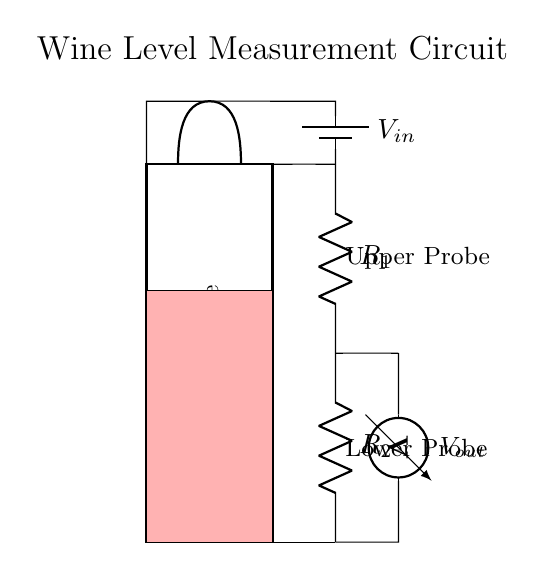What component is used to sense the voltage in this circuit? The component used to sense the voltage is a voltmeter, which is designed to measure the potential difference across a component.
Answer: voltmeter What are the two resistors labeled in this circuit? The two resistors in the circuit are labeled R1 and R2, which are part of the voltage divider setup to create the output voltage.
Answer: R1 and R2 What does the red area in the circuit diagram represent? The red area in the circuit diagram represents the current liquid level inside the wine bottle, indicating how much wine is present.
Answer: liquid level How is the voltage output measured in this circuit? The voltage output is measured by connecting the voltmeter between the upper and lower probes, which indicate where the measurement occurs in relation to the resistors.
Answer: between the upper and lower probes What is the purpose of the voltage divider in this circuit? The purpose of the voltage divider is to reduce the input voltage to a lower level that can be measured precisely, allowing for accurate determination of the wine bottle level.
Answer: to reduce the input voltage What would happen to the output voltage if R1 is increased? If R1 is increased while R2 stays the same, the output voltage will increase because the ratio of the resistors in the voltage divider influences the resultant voltage.
Answer: output voltage will increase What does the label $V_{in}$ represent? The label $V_{in}$ represents the input voltage from the battery, which provides the necessary electrical energy for the circuit to function.
Answer: input voltage 